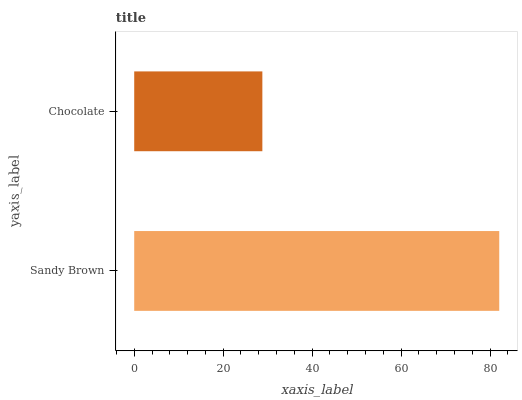Is Chocolate the minimum?
Answer yes or no. Yes. Is Sandy Brown the maximum?
Answer yes or no. Yes. Is Chocolate the maximum?
Answer yes or no. No. Is Sandy Brown greater than Chocolate?
Answer yes or no. Yes. Is Chocolate less than Sandy Brown?
Answer yes or no. Yes. Is Chocolate greater than Sandy Brown?
Answer yes or no. No. Is Sandy Brown less than Chocolate?
Answer yes or no. No. Is Sandy Brown the high median?
Answer yes or no. Yes. Is Chocolate the low median?
Answer yes or no. Yes. Is Chocolate the high median?
Answer yes or no. No. Is Sandy Brown the low median?
Answer yes or no. No. 